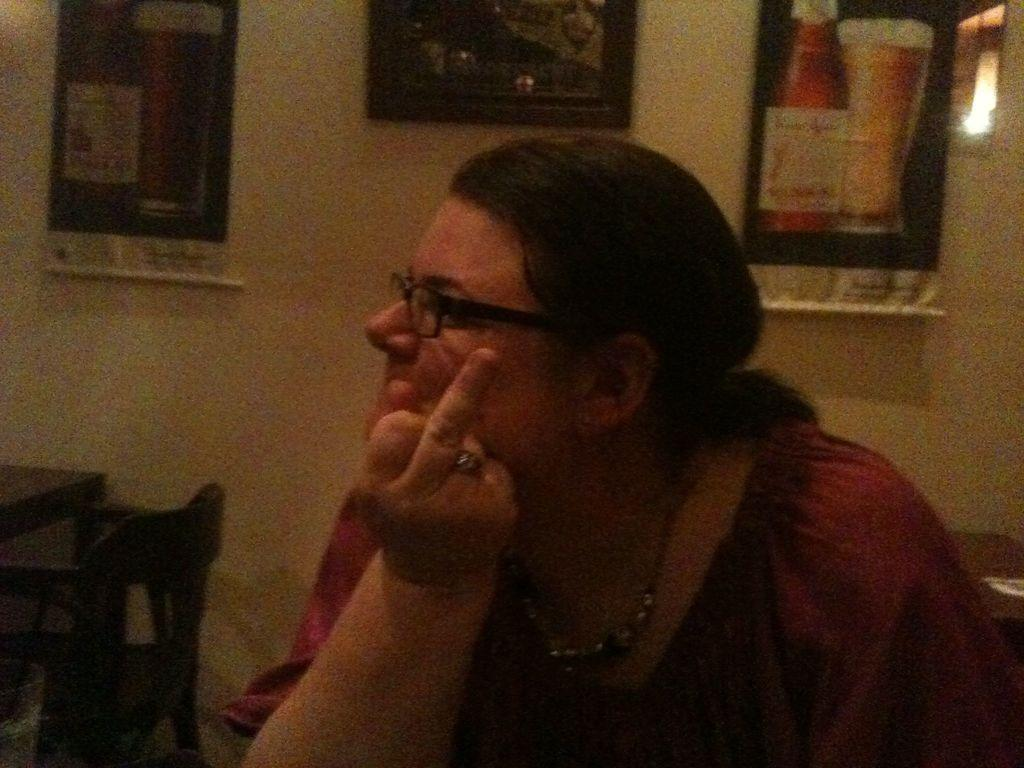Who is present in the image? There is a woman in the image. What is the woman wearing on her face? The woman is wearing spectacles. What type of furniture can be seen in the background of the image? There is a chair and a table in the background of the image. What is attached to the wall in the background of the image? There are objects attached to a wall in the background of the image. What type of skirt is the woman wearing in the image? The provided facts do not mention a skirt, so we cannot determine if the woman is wearing one or not. 